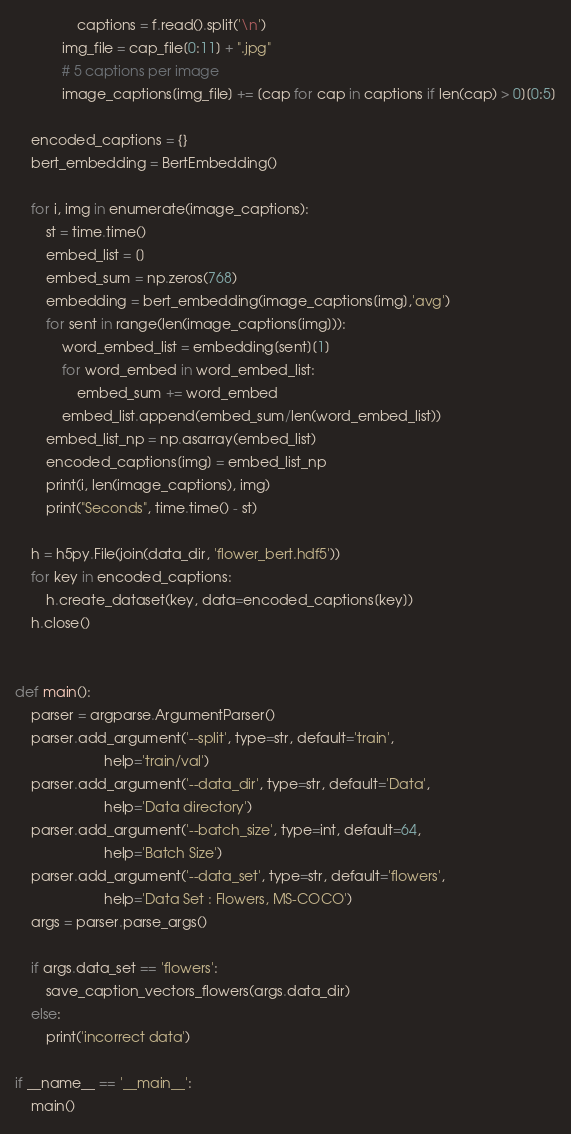Convert code to text. <code><loc_0><loc_0><loc_500><loc_500><_Python_>				captions = f.read().split('\n')
			img_file = cap_file[0:11] + ".jpg"
			# 5 captions per image
			image_captions[img_file] += [cap for cap in captions if len(cap) > 0][0:5]

	encoded_captions = {}
	bert_embedding = BertEmbedding()
	
	for i, img in enumerate(image_captions):
		st = time.time()
		embed_list = []
		embed_sum = np.zeros(768)
		embedding = bert_embedding(image_captions[img],'avg')
		for sent in range(len(image_captions[img])):
			word_embed_list = embedding[sent][1]
			for word_embed in word_embed_list:
				embed_sum += word_embed
			embed_list.append(embed_sum/len(word_embed_list))
		embed_list_np = np.asarray(embed_list)
		encoded_captions[img] = embed_list_np
		print(i, len(image_captions), img)
		print("Seconds", time.time() - st)
		
	h = h5py.File(join(data_dir, 'flower_bert.hdf5'))
	for key in encoded_captions:
		h.create_dataset(key, data=encoded_captions[key])
	h.close()


def main():
	parser = argparse.ArgumentParser()
	parser.add_argument('--split', type=str, default='train',
                       help='train/val')
	parser.add_argument('--data_dir', type=str, default='Data',
                       help='Data directory')
	parser.add_argument('--batch_size', type=int, default=64,
                       help='Batch Size')
	parser.add_argument('--data_set', type=str, default='flowers',
                       help='Data Set : Flowers, MS-COCO')
	args = parser.parse_args()
	
	if args.data_set == 'flowers':
		save_caption_vectors_flowers(args.data_dir)
	else:
		print('incorrect data')

if __name__ == '__main__':
	main()

</code> 